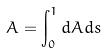<formula> <loc_0><loc_0><loc_500><loc_500>A = \int _ { 0 } ^ { 1 } d A d s</formula> 